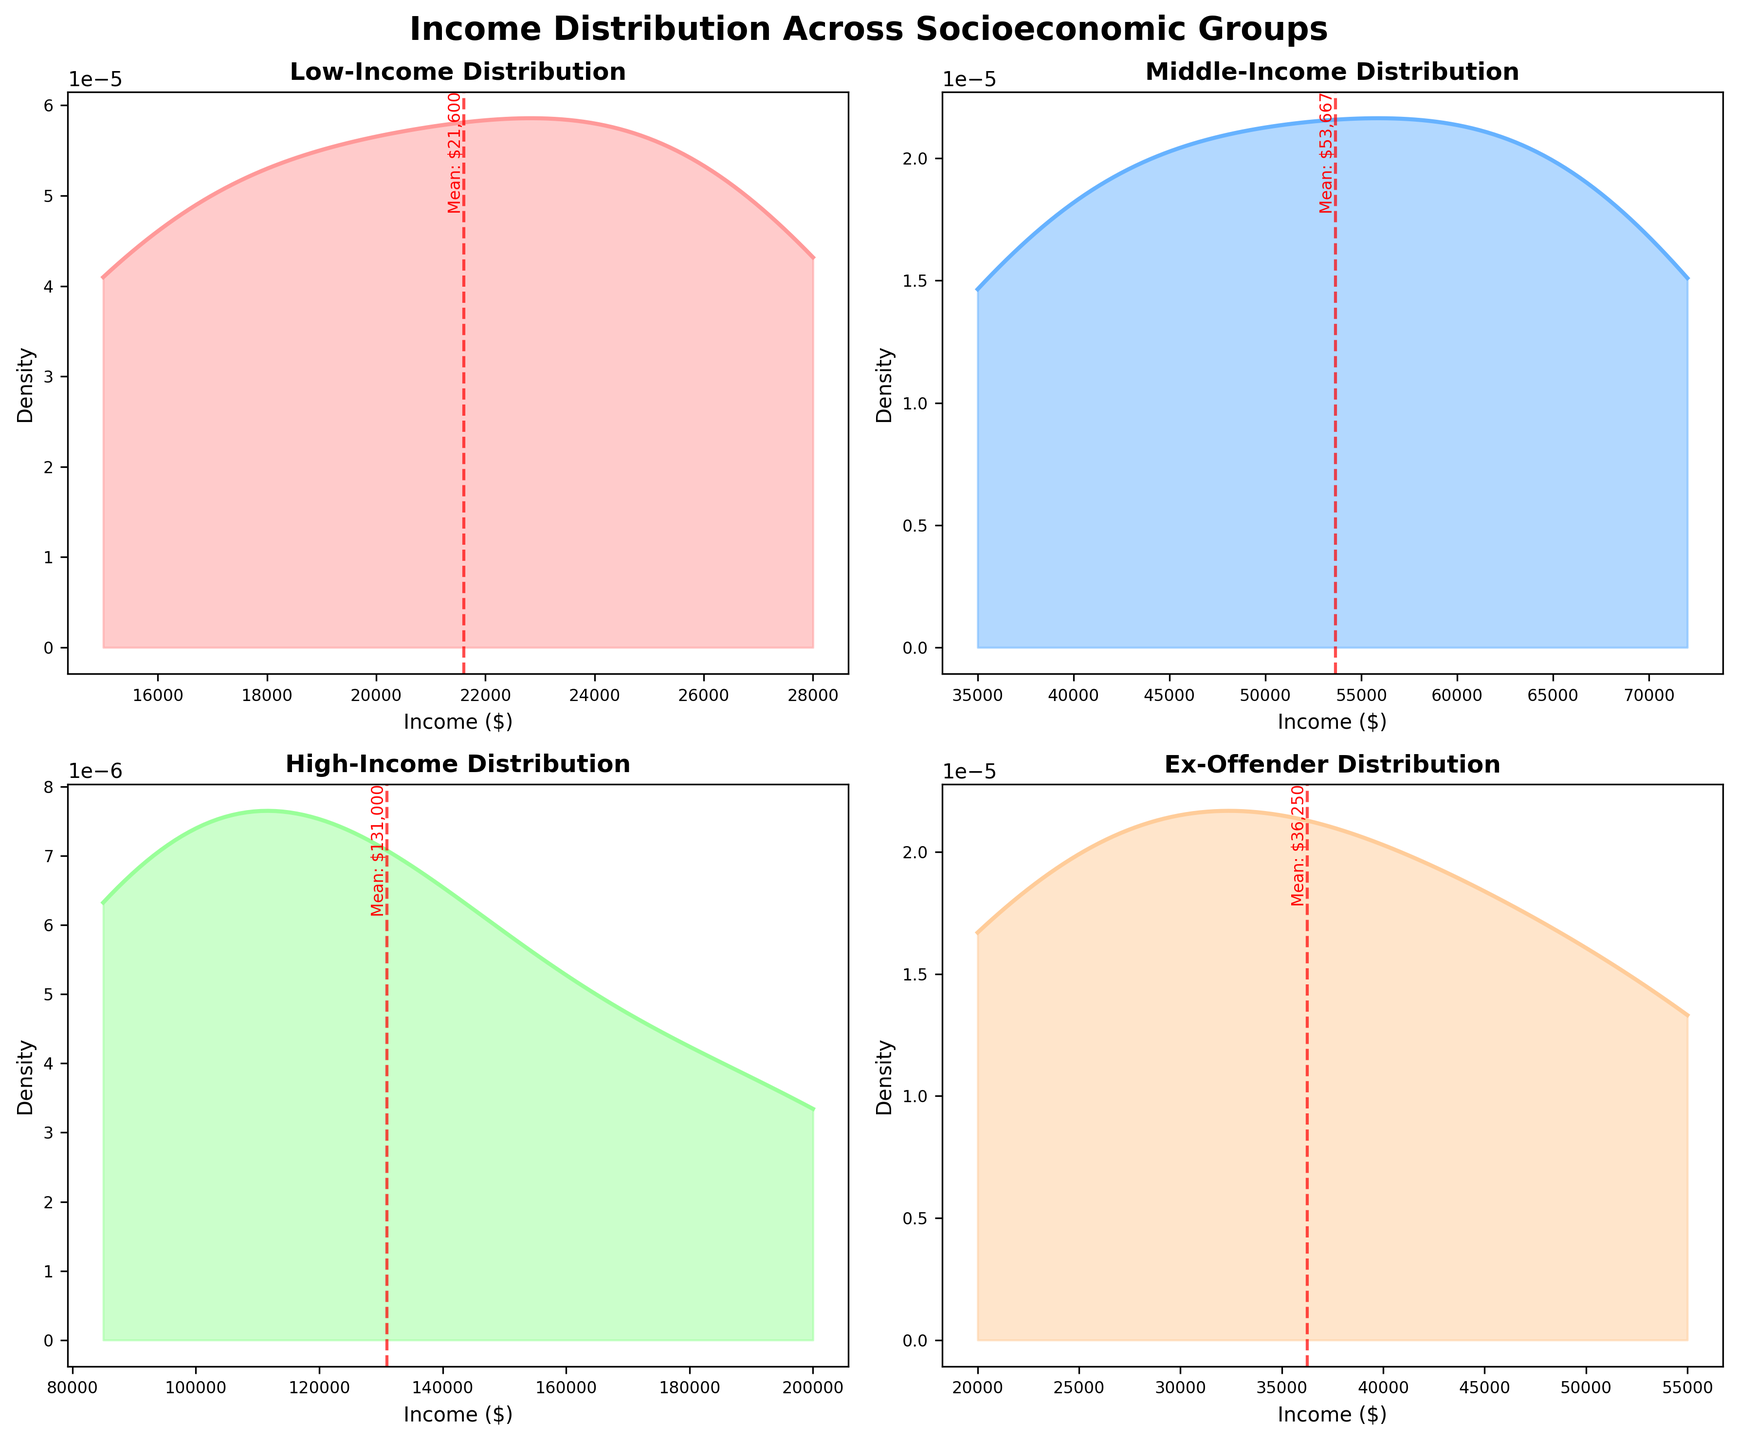What's the title of the figure? The title is located at the top of the figure.
Answer: Income Distribution Across Socioeconomic Groups Which group has the highest average income? The mean income for each group is marked by a red dashed line annotated with the mean value. The $200,000 mean income is the highest and belongs to the High-Income group.
Answer: High-Income What is the income range of the Low-Income group shown in the plot? The x-axis of the Low-Income subplot shows the range of incomes from the minimum to the maximum.
Answer: $15,000 to $28,000 Which socioeconomic group has a peak density at the lowest income? The density peak at the lowest income level belongs to the Working Class group, visible in the Low-Income plot's high-density area near $15,000.
Answer: Working Class Compare the spread of incomes between the Middle-Income and Ex-Offender groups. The width of the density plot indicates the spread of incomes. The Middle-Income group has a spread from $35,000 to $72,000, whereas the Ex-Offender group ranges from $20,000 to $55,000, showing Ex-Offender incomes are more narrowly distributed.
Answer: Middle-Income has a wider spread What's the mean income of the Ex-Offender group? The red dashed line in the Ex-Offender subplot marks the mean income at approximately $35,000.
Answer: $35,000 How do the income distributions of the Middle-Income and High-Income groups differ? By comparing the density plots, the Middle-Income group has a more evenly distributed density while the High-Income group shows higher density peaks at specific income levels, indicating more income clustering.
Answer: High-Income has higher peaks Which subplot shows the widest range of incomes? By observing the x-axes of each subplot, the High-Income group has the widest range of incomes, from $85,000 to $200,000.
Answer: High-Income Is there an overlap in the income ranges of Lower Middle Class in the Middle-Income and Ex-Offender groups? By inspecting the density plots, both subplots show that Lower Middle Class incomes range from approximately $30,000 to $42,000.
Answer: Yes Which group's income distribution is most skewed towards higher incomes? The High-Income group's distribution is more skewed towards higher incomes, visible through the density increasingly rising with income.
Answer: High-Income 